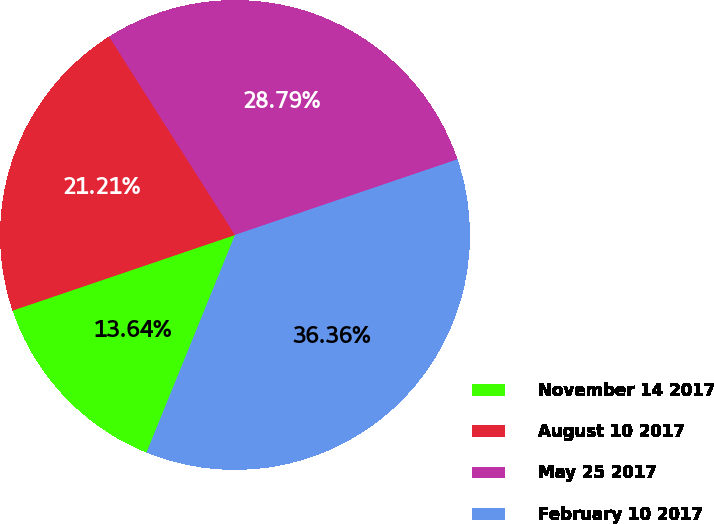Convert chart. <chart><loc_0><loc_0><loc_500><loc_500><pie_chart><fcel>November 14 2017<fcel>August 10 2017<fcel>May 25 2017<fcel>February 10 2017<nl><fcel>13.64%<fcel>21.21%<fcel>28.79%<fcel>36.36%<nl></chart> 